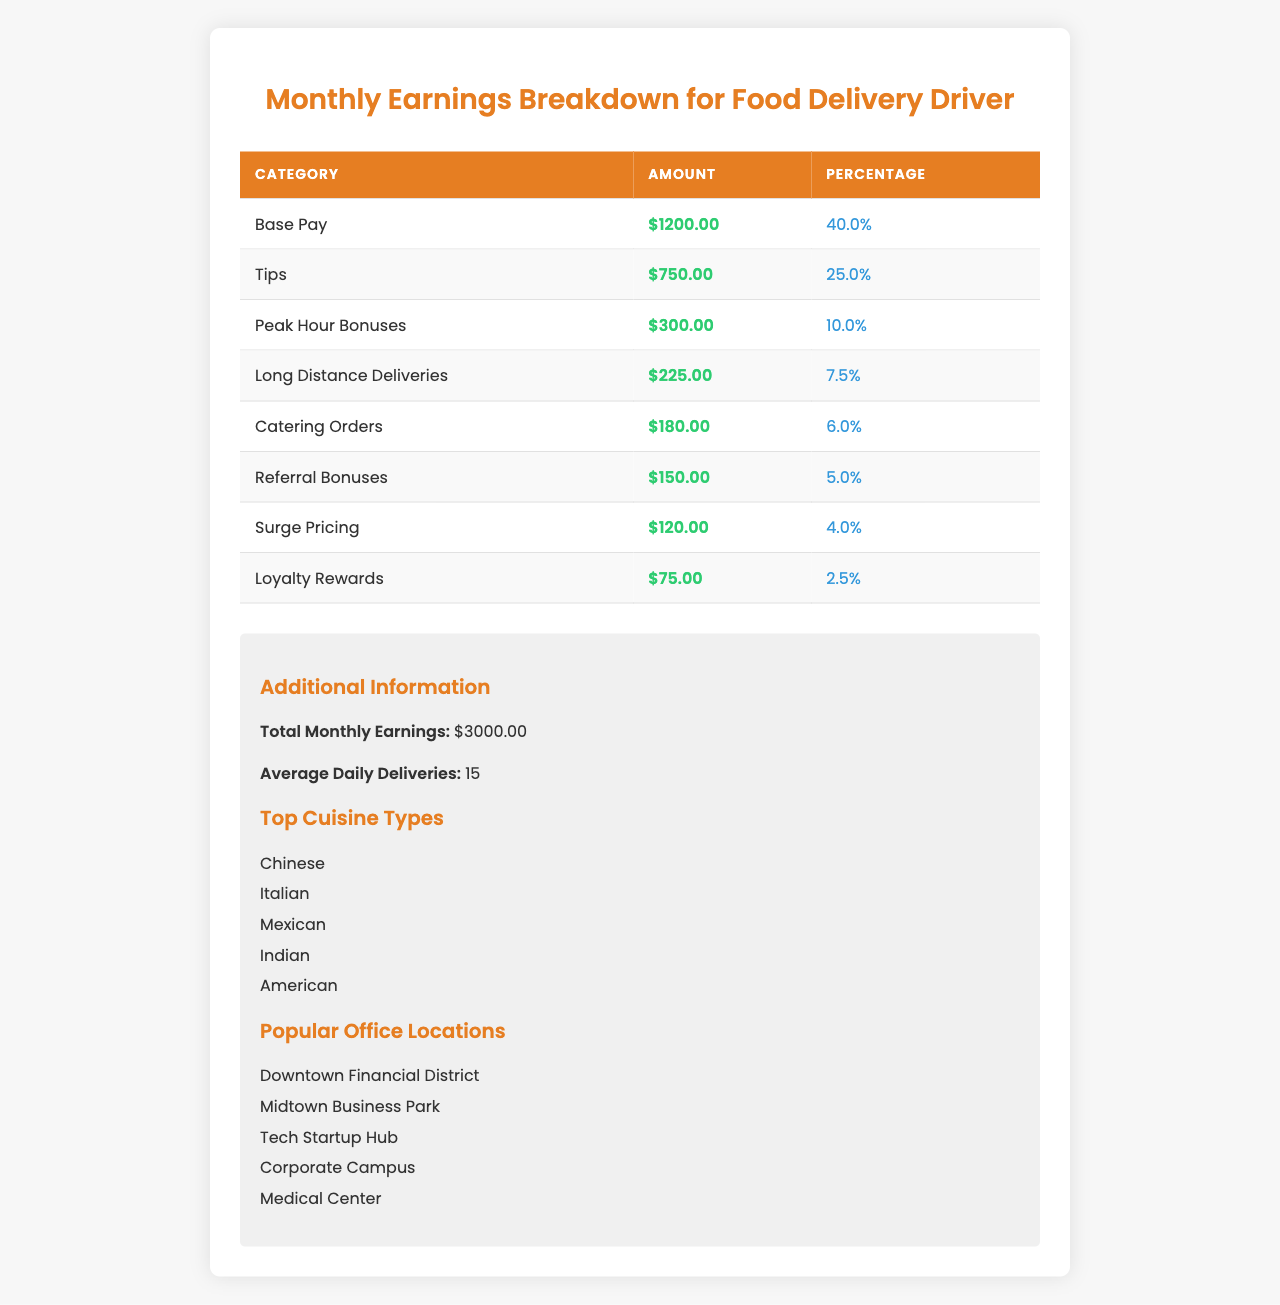What is the total amount earned from Tips? The category "Tips" in the table shows an amount of $750.00 as the earnings from tips.
Answer: $750.00 What percentage of the total earnings comes from Base Pay? The "Base Pay" category accounts for 40.0% of the total earnings, which is shown next to the Base Pay amount in the table.
Answer: 40.0% How much more is earned from Tips compared to Referral Bonuses? Tips earned $750.00 and Referral Bonuses earned $150.00. The difference is calculated as $750.00 - $150.00 = $600.00.
Answer: $600.00 Is the amount earned from Peak Hour Bonuses greater than that from Long Distance Deliveries? The table shows that "Peak Hour Bonuses" amount to $300.00 while "Long Distance Deliveries" amount to $225.00. Since $300.00 is greater than $225.00, the answer is yes.
Answer: Yes What is the combined total for Catering Orders and Loyal Rewards? "Catering Orders" amounts to $180.00 and "Loyalty Rewards" to $75.00. Adding these gives $180.00 + $75.00 = $255.00.
Answer: $255.00 Which earnings category contributed the least to the total earnings? The "Loyalty Rewards" category has the smallest amount at $75.00, which is the lowest in the breakdown.
Answer: $75.00 If the average daily deliveries are 15, what are the total deliveries made in a month (assuming 30 days)? To find the total, multiply the average daily deliveries (15) by the number of days in a month (30): 15 * 30 = 450 total deliveries.
Answer: 450 What fraction of the total monthly earnings is made up by Long Distance Deliveries? Long Distance Deliveries earned $225.00 and the total monthly earnings are $3000.00. The fraction is calculated as $225.00 / $3000.00, which simplifies to 0.075 or 7.5%.
Answer: 7.5% If each region listed as a popular office location received an equal number of deliveries, how many deliveries would each location have on average? There are 5 popular office locations, and with an average of 450 total deliveries in the month, we divide 450 by 5: 450 / 5 = 90. Each location would have an average of 90 deliveries.
Answer: 90 What is the total amount from all earnings categories combined? To find the total, we sum all amounts from each category: 1200 + 750 + 300 + 225 + 180 + 150 + 120 + 75 = 3000. The table confirms this total.
Answer: $3000.00 